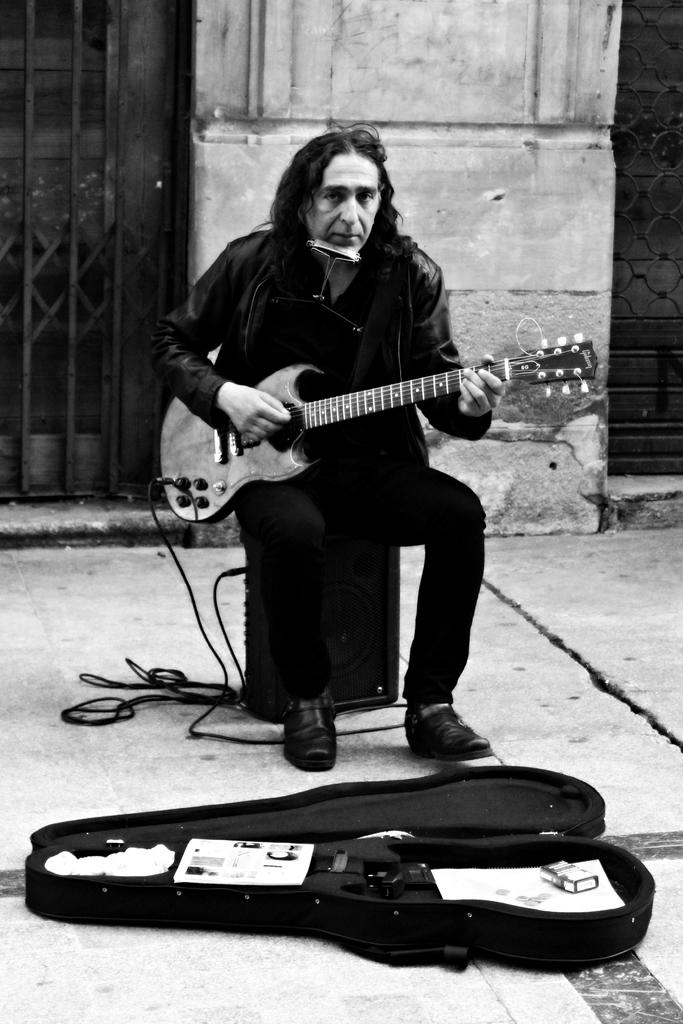What is the main subject of the image? There is a person in the image. What is the person doing in the image? The person is sitting and playing a guitar. What type of drawer is visible in the image? There is no drawer present in the image. What is the reason behind the person playing the guitar in the image? The image does not provide any information about the person's motivation for playing the guitar. 